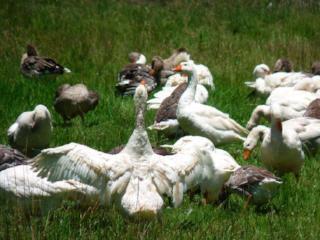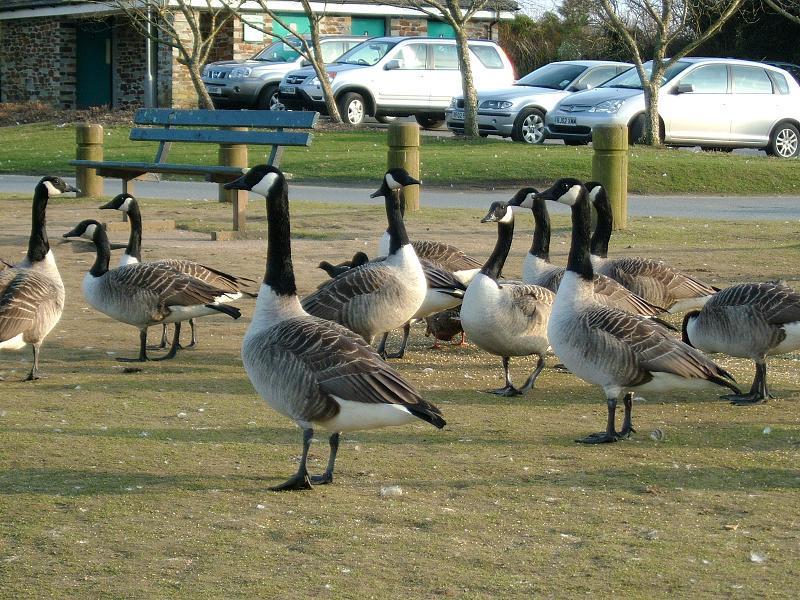The first image is the image on the left, the second image is the image on the right. For the images displayed, is the sentence "An image shows at least eight solid-white ducks moving toward the camera." factually correct? Answer yes or no. No. 